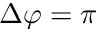<formula> <loc_0><loc_0><loc_500><loc_500>\Delta \varphi = \pi</formula> 